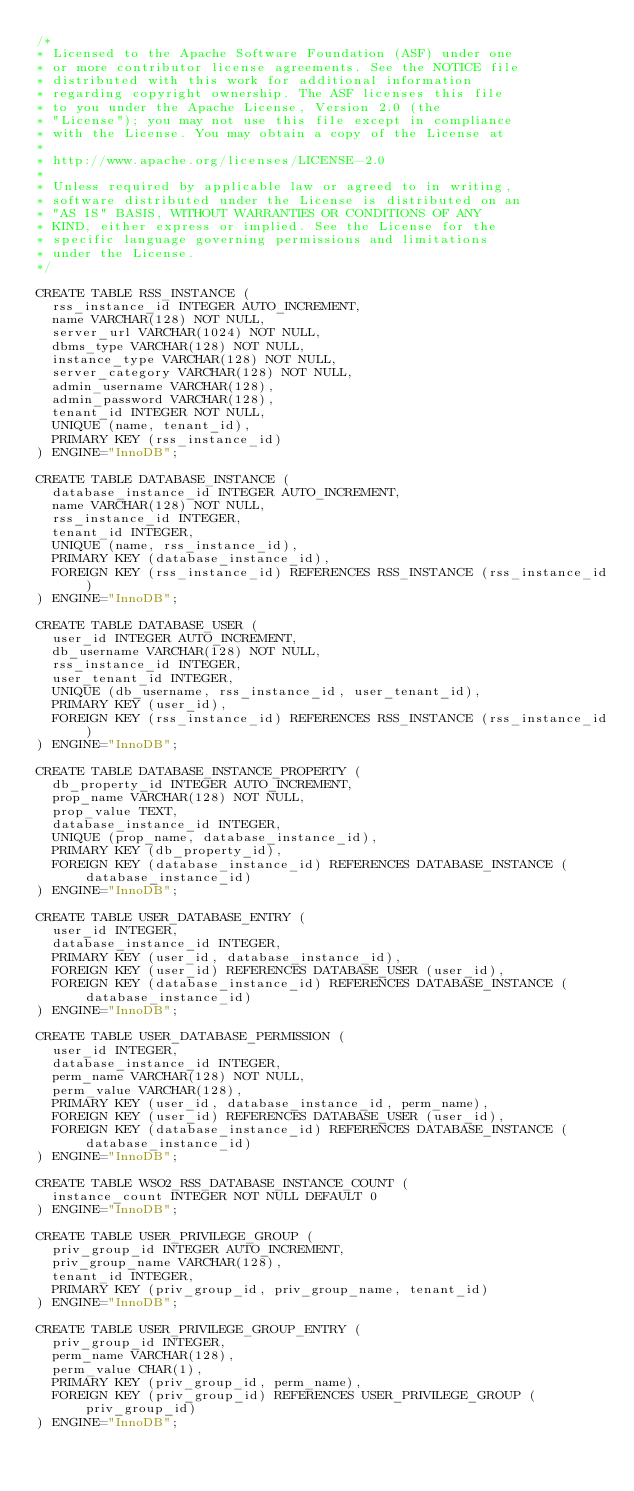Convert code to text. <code><loc_0><loc_0><loc_500><loc_500><_SQL_>/*
* Licensed to the Apache Software Foundation (ASF) under one
* or more contributor license agreements. See the NOTICE file
* distributed with this work for additional information
* regarding copyright ownership. The ASF licenses this file
* to you under the Apache License, Version 2.0 (the
* "License"); you may not use this file except in compliance
* with the License. You may obtain a copy of the License at
*
* http://www.apache.org/licenses/LICENSE-2.0
*
* Unless required by applicable law or agreed to in writing,
* software distributed under the License is distributed on an
* "AS IS" BASIS, WITHOUT WARRANTIES OR CONDITIONS OF ANY
* KIND, either express or implied. See the License for the
* specific language governing permissions and limitations
* under the License.
*/ 

CREATE TABLE RSS_INSTANCE (
  rss_instance_id INTEGER AUTO_INCREMENT,
  name VARCHAR(128) NOT NULL,
  server_url VARCHAR(1024) NOT NULL,
  dbms_type VARCHAR(128) NOT NULL,
  instance_type VARCHAR(128) NOT NULL,
  server_category VARCHAR(128) NOT NULL,
  admin_username VARCHAR(128),
  admin_password VARCHAR(128),
  tenant_id INTEGER NOT NULL,
  UNIQUE (name, tenant_id),
  PRIMARY KEY (rss_instance_id)
) ENGINE="InnoDB";

CREATE TABLE DATABASE_INSTANCE (
  database_instance_id INTEGER AUTO_INCREMENT,
  name VARCHAR(128) NOT NULL,
  rss_instance_id INTEGER,
  tenant_id INTEGER,
  UNIQUE (name, rss_instance_id),
  PRIMARY KEY (database_instance_id),
  FOREIGN KEY (rss_instance_id) REFERENCES RSS_INSTANCE (rss_instance_id)
) ENGINE="InnoDB";

CREATE TABLE DATABASE_USER (
  user_id INTEGER AUTO_INCREMENT,
  db_username VARCHAR(128) NOT NULL,
  rss_instance_id INTEGER,
  user_tenant_id INTEGER,
  UNIQUE (db_username, rss_instance_id, user_tenant_id),
  PRIMARY KEY (user_id),
  FOREIGN KEY (rss_instance_id) REFERENCES RSS_INSTANCE (rss_instance_id)
) ENGINE="InnoDB";

CREATE TABLE DATABASE_INSTANCE_PROPERTY (
  db_property_id INTEGER AUTO_INCREMENT,
  prop_name VARCHAR(128) NOT NULL,
  prop_value TEXT,
  database_instance_id INTEGER,
  UNIQUE (prop_name, database_instance_id),
  PRIMARY KEY (db_property_id),
  FOREIGN KEY (database_instance_id) REFERENCES DATABASE_INSTANCE (database_instance_id)
) ENGINE="InnoDB";

CREATE TABLE USER_DATABASE_ENTRY (
  user_id INTEGER,
  database_instance_id INTEGER,
  PRIMARY KEY (user_id, database_instance_id),
  FOREIGN KEY (user_id) REFERENCES DATABASE_USER (user_id),
  FOREIGN KEY (database_instance_id) REFERENCES DATABASE_INSTANCE (database_instance_id)
) ENGINE="InnoDB";

CREATE TABLE USER_DATABASE_PERMISSION (
  user_id INTEGER,
  database_instance_id INTEGER,
  perm_name VARCHAR(128) NOT NULL,
  perm_value VARCHAR(128),
  PRIMARY KEY (user_id, database_instance_id, perm_name),
  FOREIGN KEY (user_id) REFERENCES DATABASE_USER (user_id),
  FOREIGN KEY (database_instance_id) REFERENCES DATABASE_INSTANCE (database_instance_id)
) ENGINE="InnoDB";

CREATE TABLE WSO2_RSS_DATABASE_INSTANCE_COUNT (
  instance_count INTEGER NOT NULL DEFAULT 0
) ENGINE="InnoDB";

CREATE TABLE USER_PRIVILEGE_GROUP (
  priv_group_id INTEGER AUTO_INCREMENT,
  priv_group_name VARCHAR(128),
  tenant_id INTEGER,
  PRIMARY KEY (priv_group_id, priv_group_name, tenant_id)
) ENGINE="InnoDB";

CREATE TABLE USER_PRIVILEGE_GROUP_ENTRY (
  priv_group_id INTEGER,
  perm_name VARCHAR(128),
  perm_value CHAR(1),
  PRIMARY KEY (priv_group_id, perm_name),
  FOREIGN KEY (priv_group_id) REFERENCES USER_PRIVILEGE_GROUP (priv_group_id)
) ENGINE="InnoDB";
</code> 